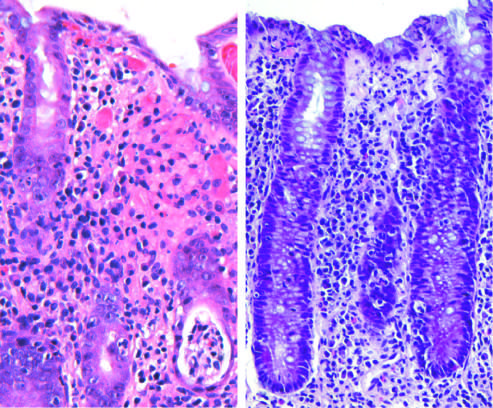what is presented lower right?
Answer the question using a single word or phrase. A crypt abscess 